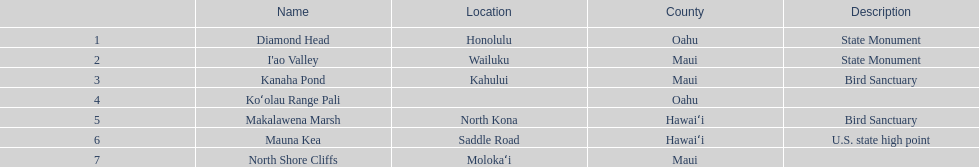What is the only name listed without a location? Koʻolau Range Pali. 